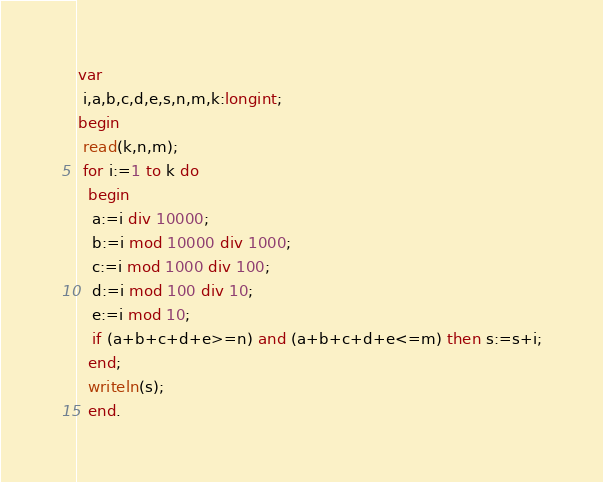Convert code to text. <code><loc_0><loc_0><loc_500><loc_500><_Pascal_>var
 i,a,b,c,d,e,s,n,m,k:longint;
begin
 read(k,n,m);
 for i:=1 to k do 
  begin
   a:=i div 10000;
   b:=i mod 10000 div 1000;
   c:=i mod 1000 div 100;
   d:=i mod 100 div 10;
   e:=i mod 10;
   if (a+b+c+d+e>=n) and (a+b+c+d+e<=m) then s:=s+i;
  end;
  writeln(s);
  end.</code> 